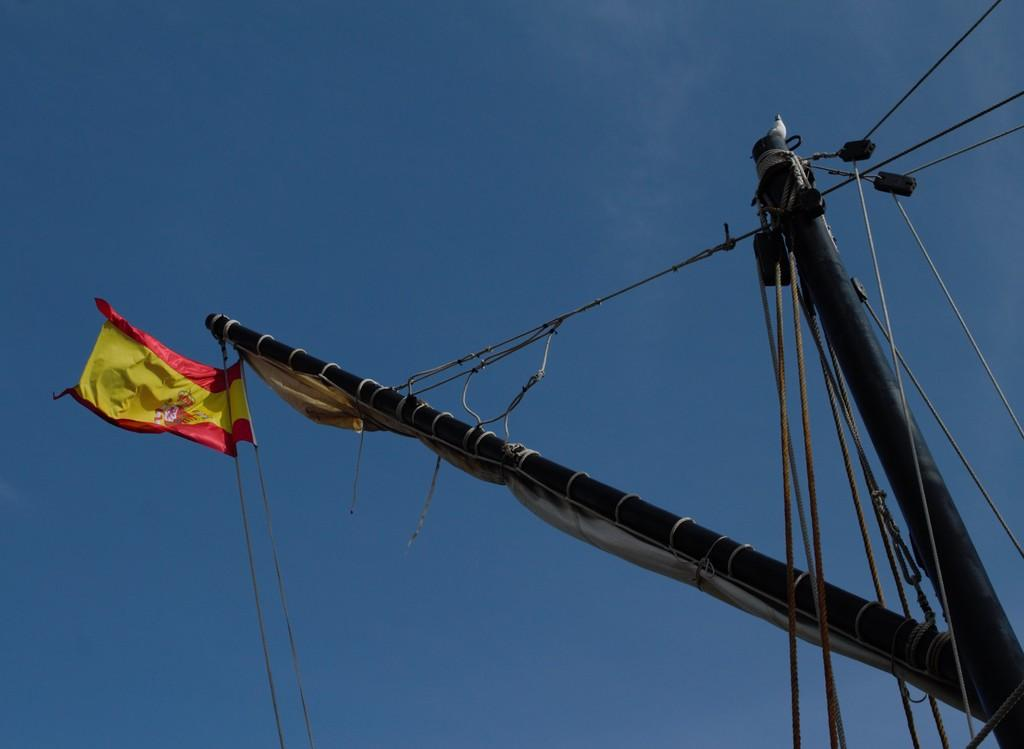What is the main object in the image? There is a pole in the image. What is connected to the pole? There are ropes attached to the pole, and a flag is attached to the pole as well. What is at the top of the pole? There is a bird at the top of the pole. What can be seen in the background of the image? The sky is visible in the background of the image. What type of quilt is being used to cover the station in the image? There is no station or quilt present in the image; it features a pole with ropes, a flag, and a bird at the top, along with a visible sky in the background. 